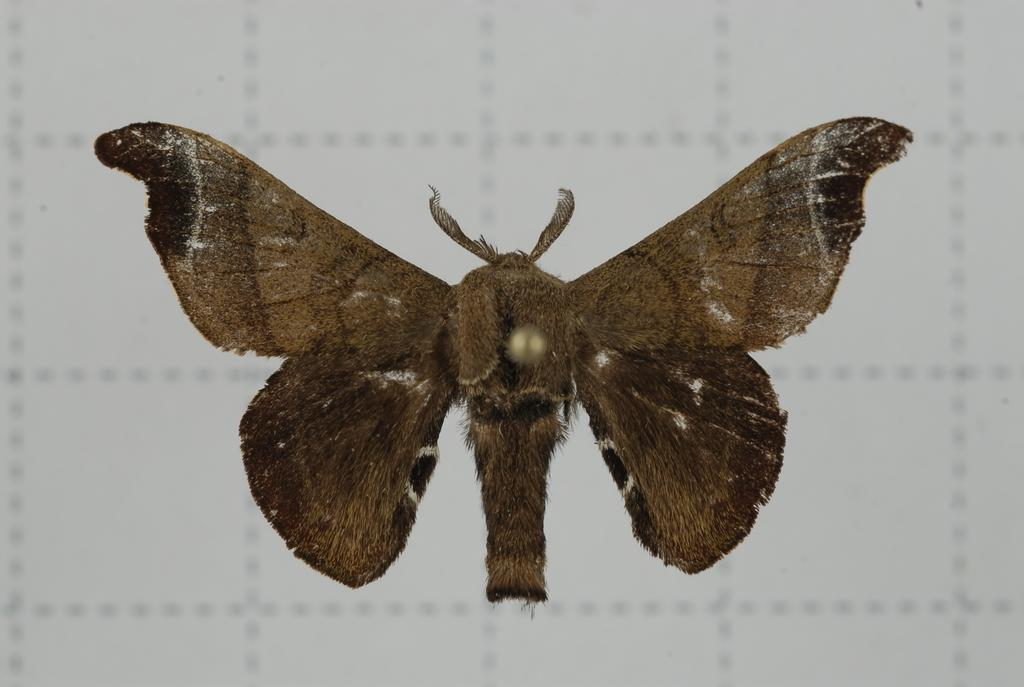What type of creature is present in the image? There is a butterfly in the image. What color is the butterfly? The butterfly is brown in color. What is the butterfly doing in the image? The butterfly is flying in the air. What type of fan can be seen in the image? There is no fan present in the image; it features a brown butterfly flying in the air. What show is the butterfly attending in the image? Butterflies do not attend shows, and there is no indication of any event or gathering in the image. 